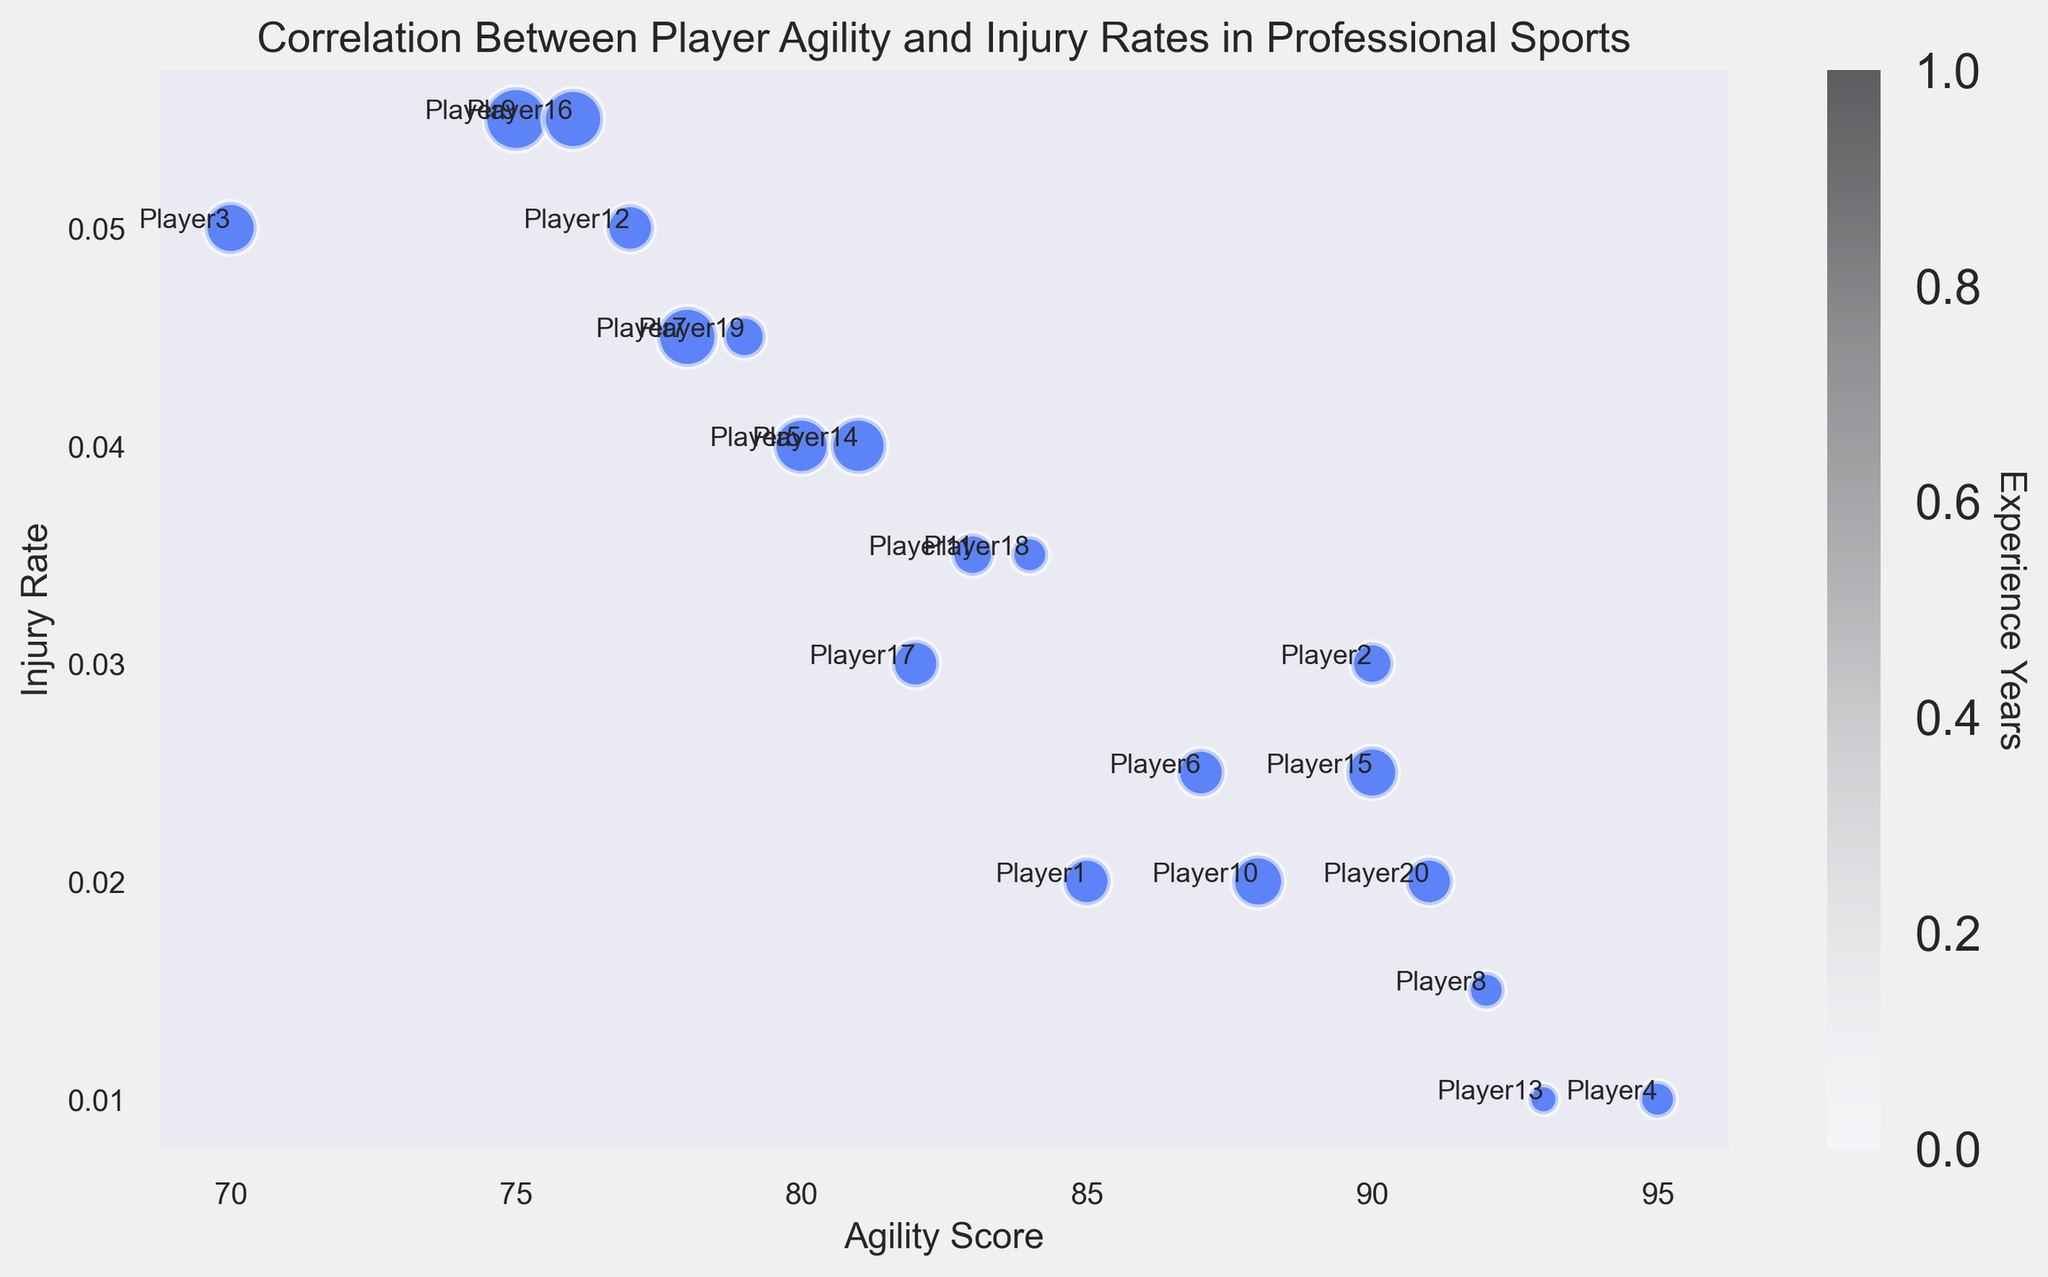Which player has the highest agility score? The bubble chart shows individual player names along the X and Y axes. The highest value on the X-axis (Agility Score) is 95, and the player labeled near this point is Player4.
Answer: Player4 Which player has the lowest injury rate? The bubble chart shows injury rates on the Y-axis. The lowest value on the Y-axis (Injury Rate) is 0.01, and the players labeled near this point are Player4 and Player13.
Answer: Player4 and Player13 What is the average agility score of players with an injury rate lower than 0.02? There are four players (Player4, Player8, Player13, and Player20) with injury rates lower than 0.02. Their agility scores are 95, 92, 93, and 91. The sum of these scores is (95 + 92 + 93 + 91) = 371, and the average is 371/4 = 92.75.
Answer: 92.75 Which player with more than 5 years of experience has the lowest injury rate? Players with more than 5 years of experience are Players 3, 5, 7, 9, 10, 12, 14, and 16. Among these, Player10 has the lowest injury rate of 0.02.
Answer: Player10 Which player has the largest bubble size, and what does it signify? The bubble size represents experience years. Player9 has the largest bubble, corresponding to 9 years of experience, as indicated by the size of the bubbles and confirmed through the color bar.
Answer: Player9 Is there a player with high agility (above 90) and a high injury rate (above 0.03)? Checking the bubbles with an agility score above 90 (Players 4, 8, 13, and 20) and looking for injury rates above 0.03 shows none of these players meet the criterion.
Answer: No What is the general trend between agility score and injury rate? Observing the scatter points, as agility scores increase, injury rates generally appear to decrease, indicating an inverse relationship. Higher agility scores tend to have lower injury rates.
Answer: Inverse relationship Which players have an injury rate of 0.05, and what are their respective agility scores? Players with an injury rate of 0.05 are Players 3, 7, and 12. Their agility scores are 70, 78, and 77, respectively.
Answer: Player3: 70, Player7: 78, Player12: 77 How many players have an agility score greater than 85? Counting the players with agility scores greater than 85 (Players 1, 2, 4, 6, 8, 10, 13, 15, 20), there are 9 such players.
Answer: 9 